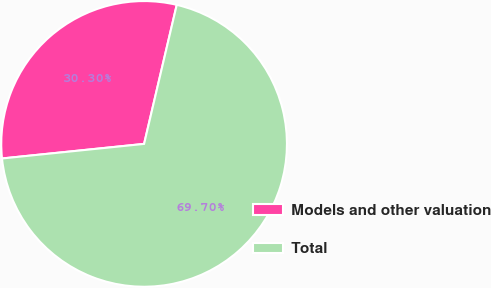Convert chart to OTSL. <chart><loc_0><loc_0><loc_500><loc_500><pie_chart><fcel>Models and other valuation<fcel>Total<nl><fcel>30.3%<fcel>69.7%<nl></chart> 